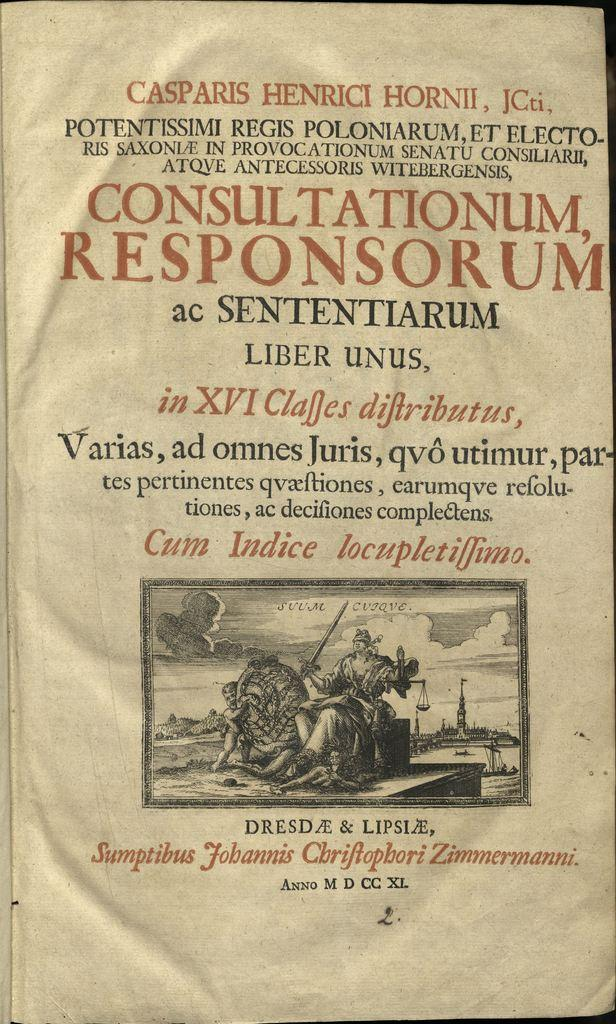<image>
Write a terse but informative summary of the picture. Casparis Henrici HornII JCti. Consultationum responsorum ac sententiarum and liber unus. 